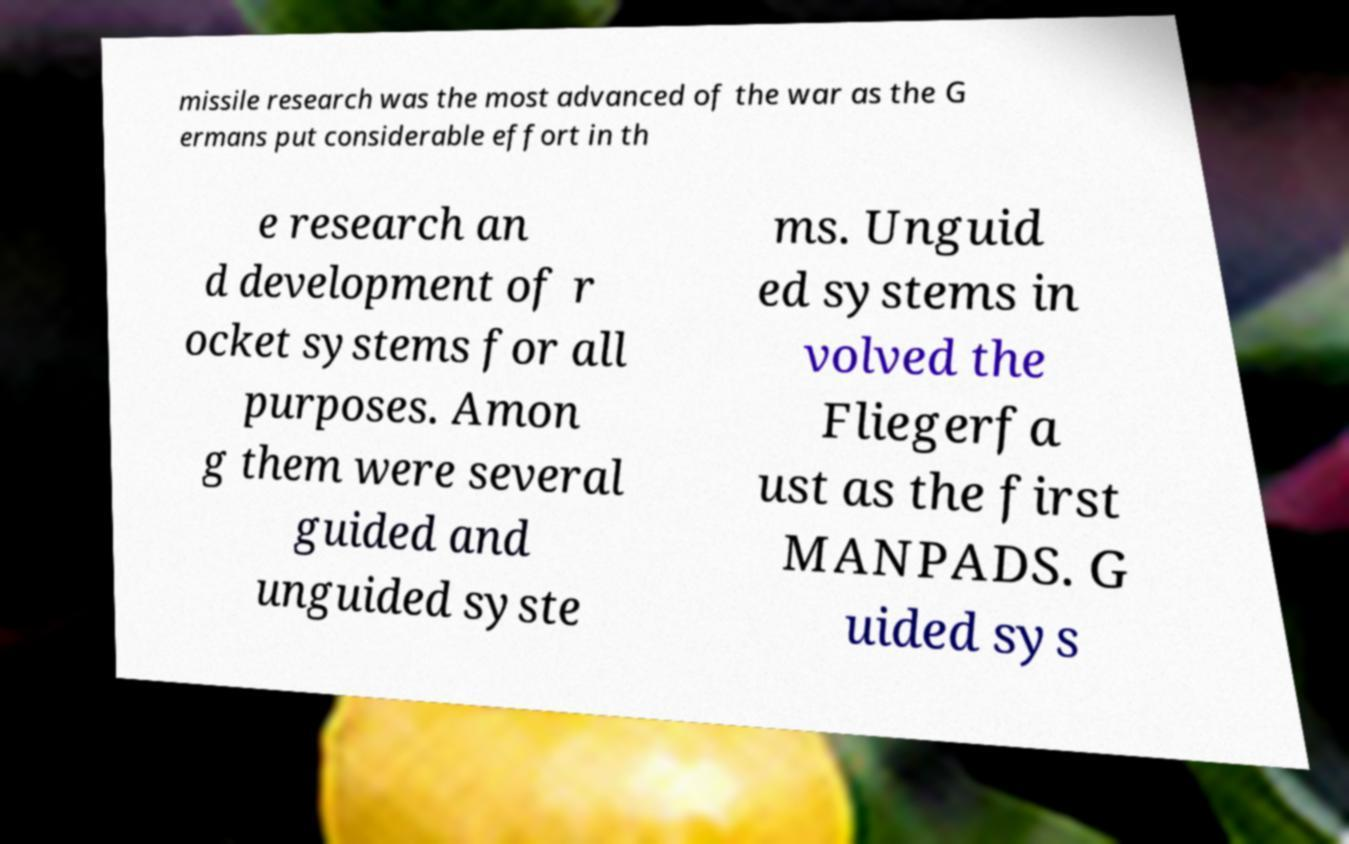Please identify and transcribe the text found in this image. missile research was the most advanced of the war as the G ermans put considerable effort in th e research an d development of r ocket systems for all purposes. Amon g them were several guided and unguided syste ms. Unguid ed systems in volved the Fliegerfa ust as the first MANPADS. G uided sys 